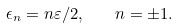<formula> <loc_0><loc_0><loc_500><loc_500>\epsilon _ { n } = n \varepsilon / 2 , \quad n = \pm 1 .</formula> 